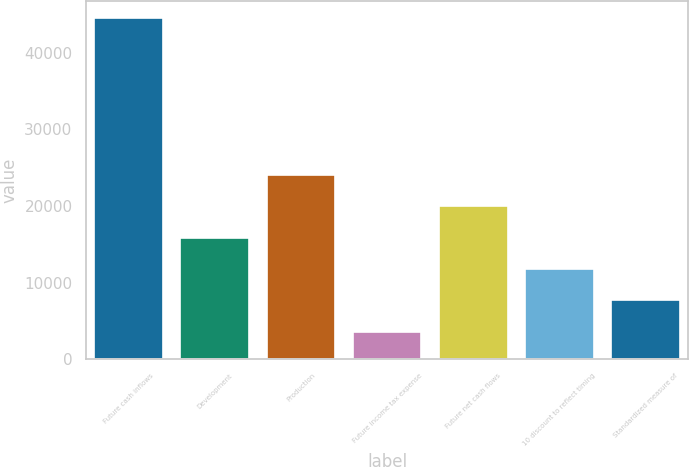Convert chart. <chart><loc_0><loc_0><loc_500><loc_500><bar_chart><fcel>Future cash inflows<fcel>Development<fcel>Production<fcel>Future income tax expense<fcel>Future net cash flows<fcel>10 discount to reflect timing<fcel>Standardized measure of<nl><fcel>44571<fcel>15871.7<fcel>24071.5<fcel>3572<fcel>19971.6<fcel>11771.8<fcel>7671.9<nl></chart> 